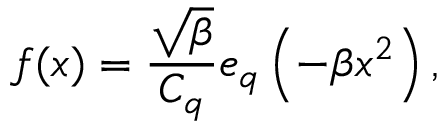Convert formula to latex. <formula><loc_0><loc_0><loc_500><loc_500>f ( x ) = \frac { \sqrt { \beta } } { C _ { q } } e _ { q } \left ( - \beta x ^ { 2 } \right ) ,</formula> 